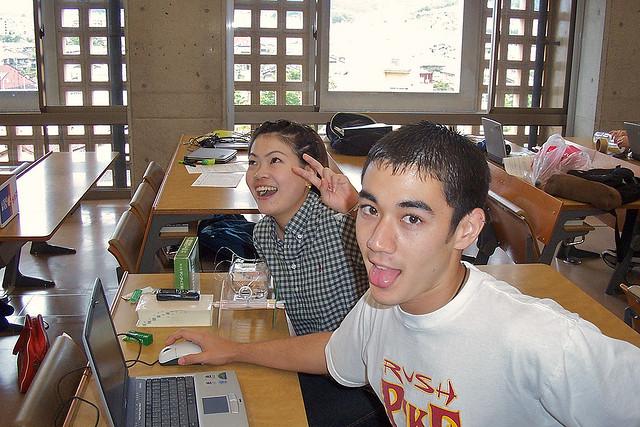Is the mouse wireless?
Short answer required. No. Is this in a classroom?
Short answer required. Yes. What are they doing?
Concise answer only. Posing. Do they know their picture is being taken?
Give a very brief answer. Yes. 